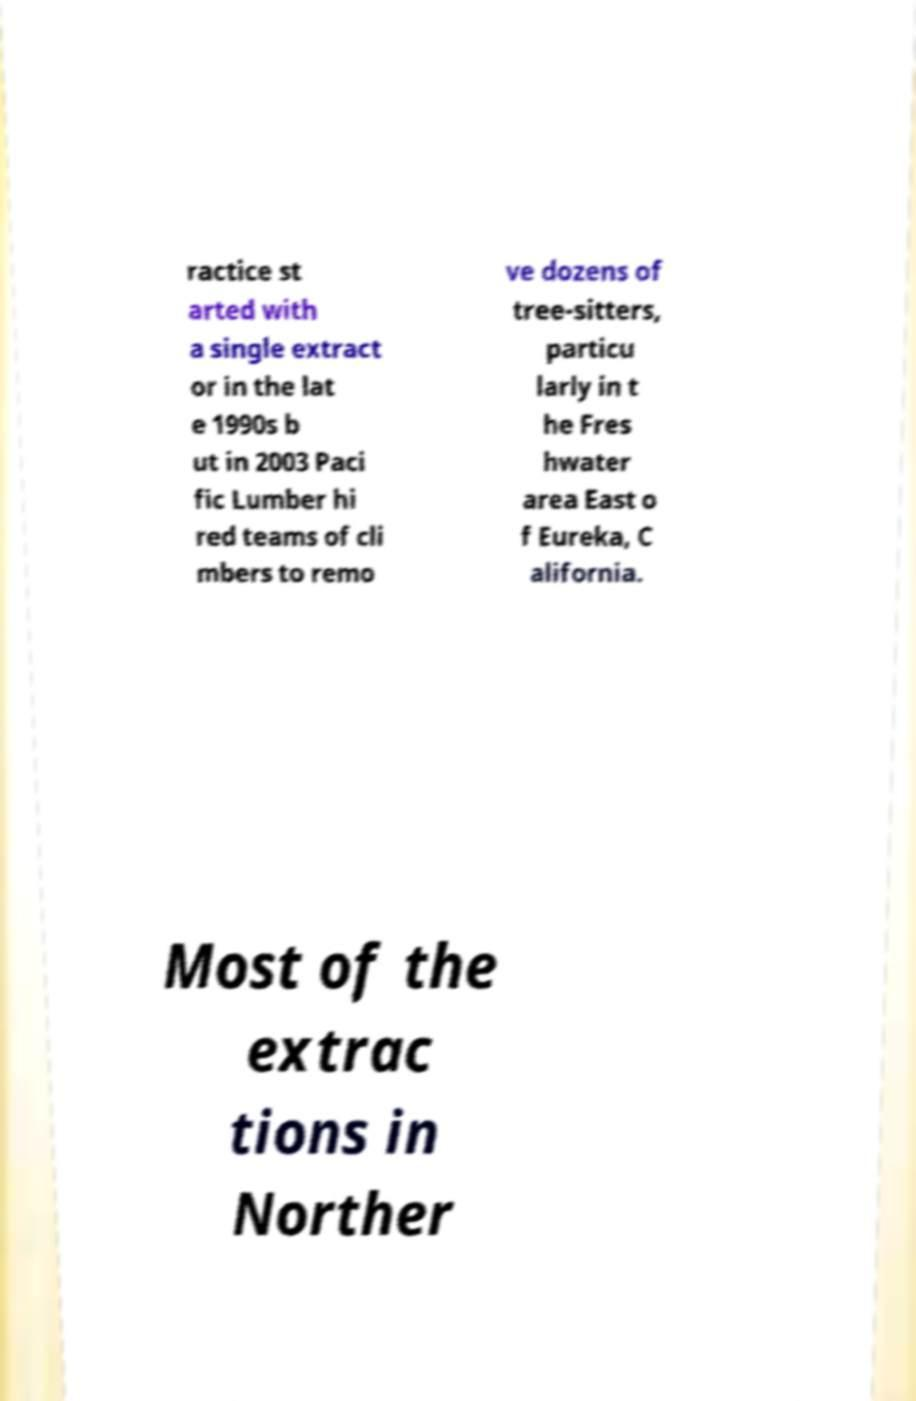Can you accurately transcribe the text from the provided image for me? ractice st arted with a single extract or in the lat e 1990s b ut in 2003 Paci fic Lumber hi red teams of cli mbers to remo ve dozens of tree-sitters, particu larly in t he Fres hwater area East o f Eureka, C alifornia. Most of the extrac tions in Norther 